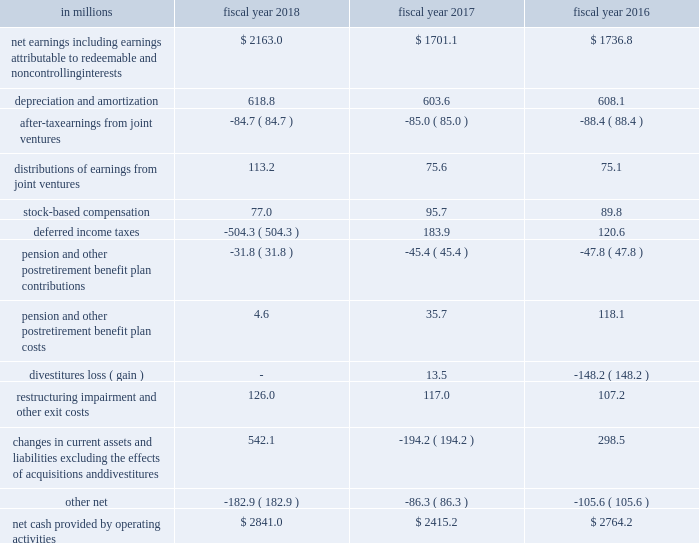Cash flows from operations .
In fiscal 2018 , cash provided by operations was $ 2.8 billion compared to $ 2.4 billion in fiscal 2017 .
The $ 426 million increase was primarily driven by the $ 462 million increase in net earnings and the $ 736 million change in current assets and liabilities , partially offset by a $ 688 million change in deferred income taxes .
The change in deferred income taxes was primarily related to the $ 638 million provisional benefit from revaluing our net u.s .
Deferred tax liabilities to reflect the new u.s .
Corporate tax rate as a result of the tcja .
The $ 736 million change in current assets and liabilities was primarily due to changes in accounts payable of $ 476 million related to the extension of payment terms and timing of payments , and $ 264 million of changes in other current liabilities primarily driven by changes in income taxes payable , trade and advertising accruals , and incentive accruals .
We strive to grow core working capital at or below the rate of growth in our net sales .
For fiscal 2018 , core working capital decreased 27 percent , compared to a net sales increase of 1 percent .
In fiscal 2017 , core working capital increased 9 percent , compared to a net sales decline of 6 percent , and in fiscal 2016 , core working capital decreased 41 percent , compared to net sales decline of 6 percent .
In fiscal 2017 , our operations generated $ 2.4 billion of cash , compared to $ 2.8 billion in fiscal 2016 .
The $ 349 million decrease was primarily driven by a $ 493 million change in current assets and liabilities .
The $ 493 million change in current assets and liabilities was primarily due to changes in other current liabilities driven by changes in income taxes payable , a decrease in incentive accruals , and changes in trade and advertising accruals due to reduced spending .
The change in current assets and liabilities was also impacted by the timing of accounts payable .
Additionally , we recorded a $ 14 million loss on a divestiture during fiscal 2017 , compared to a $ 148 million net gain on divestitures during fiscal 2016 , and classified the related cash flows as investing activities. .
What was percentage change in net earnings including earnings attributable to redeemable and non controlling interests from 2017 to 2018? 
Computations: ((2163.0 - 1701.1) / 1701.1)
Answer: 0.27153. 